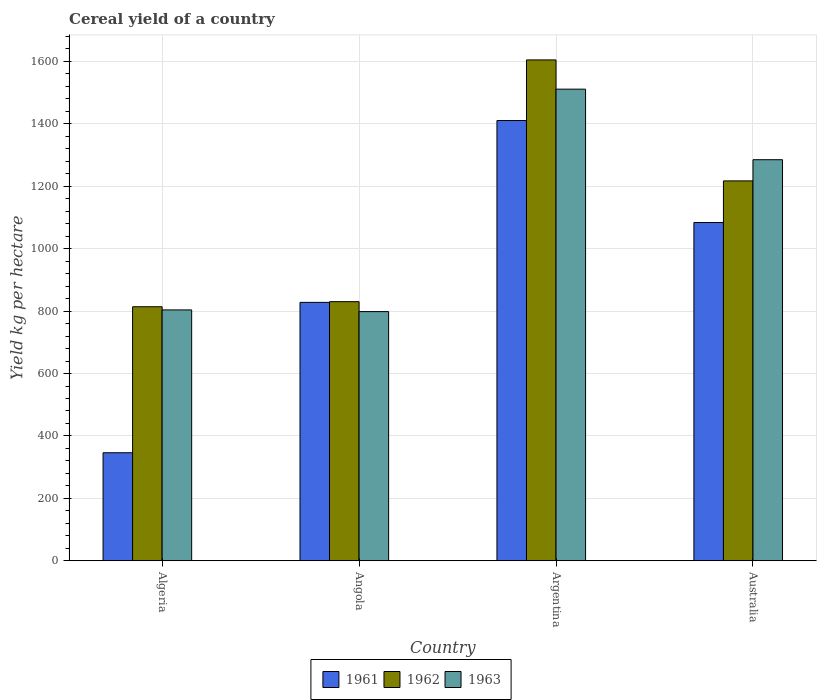Are the number of bars per tick equal to the number of legend labels?
Keep it short and to the point. Yes. Are the number of bars on each tick of the X-axis equal?
Keep it short and to the point. Yes. What is the label of the 1st group of bars from the left?
Ensure brevity in your answer.  Algeria. In how many cases, is the number of bars for a given country not equal to the number of legend labels?
Provide a succinct answer. 0. What is the total cereal yield in 1963 in Argentina?
Give a very brief answer. 1511.24. Across all countries, what is the maximum total cereal yield in 1962?
Your response must be concise. 1604.92. Across all countries, what is the minimum total cereal yield in 1963?
Your answer should be very brief. 798.45. In which country was the total cereal yield in 1961 maximum?
Offer a very short reply. Argentina. In which country was the total cereal yield in 1962 minimum?
Provide a succinct answer. Algeria. What is the total total cereal yield in 1962 in the graph?
Ensure brevity in your answer.  4466.47. What is the difference between the total cereal yield in 1961 in Algeria and that in Angola?
Keep it short and to the point. -481.85. What is the difference between the total cereal yield in 1961 in Angola and the total cereal yield in 1962 in Australia?
Keep it short and to the point. -389.26. What is the average total cereal yield in 1961 per country?
Your answer should be compact. 917.18. What is the difference between the total cereal yield of/in 1963 and total cereal yield of/in 1962 in Algeria?
Give a very brief answer. -10.17. What is the ratio of the total cereal yield in 1962 in Argentina to that in Australia?
Offer a very short reply. 1.32. Is the total cereal yield in 1962 in Angola less than that in Argentina?
Offer a very short reply. Yes. Is the difference between the total cereal yield in 1963 in Angola and Australia greater than the difference between the total cereal yield in 1962 in Angola and Australia?
Provide a short and direct response. No. What is the difference between the highest and the second highest total cereal yield in 1963?
Provide a short and direct response. -481.34. What is the difference between the highest and the lowest total cereal yield in 1961?
Your answer should be very brief. 1064.5. Is the sum of the total cereal yield in 1961 in Angola and Argentina greater than the maximum total cereal yield in 1962 across all countries?
Your answer should be compact. Yes. What does the 2nd bar from the right in Angola represents?
Give a very brief answer. 1962. Is it the case that in every country, the sum of the total cereal yield in 1962 and total cereal yield in 1963 is greater than the total cereal yield in 1961?
Offer a very short reply. Yes. How many bars are there?
Your answer should be compact. 12. How many countries are there in the graph?
Provide a short and direct response. 4. Are the values on the major ticks of Y-axis written in scientific E-notation?
Keep it short and to the point. No. Does the graph contain any zero values?
Ensure brevity in your answer.  No. How are the legend labels stacked?
Your answer should be very brief. Horizontal. What is the title of the graph?
Give a very brief answer. Cereal yield of a country. Does "1985" appear as one of the legend labels in the graph?
Offer a very short reply. No. What is the label or title of the Y-axis?
Your answer should be compact. Yield kg per hectare. What is the Yield kg per hectare of 1961 in Algeria?
Your response must be concise. 346.15. What is the Yield kg per hectare in 1962 in Algeria?
Offer a very short reply. 814. What is the Yield kg per hectare of 1963 in Algeria?
Provide a short and direct response. 803.83. What is the Yield kg per hectare of 1961 in Angola?
Offer a terse response. 828.01. What is the Yield kg per hectare in 1962 in Angola?
Your answer should be compact. 830.27. What is the Yield kg per hectare of 1963 in Angola?
Keep it short and to the point. 798.45. What is the Yield kg per hectare in 1961 in Argentina?
Your answer should be very brief. 1410.65. What is the Yield kg per hectare in 1962 in Argentina?
Give a very brief answer. 1604.92. What is the Yield kg per hectare of 1963 in Argentina?
Your response must be concise. 1511.24. What is the Yield kg per hectare in 1961 in Australia?
Provide a succinct answer. 1083.9. What is the Yield kg per hectare in 1962 in Australia?
Keep it short and to the point. 1217.27. What is the Yield kg per hectare in 1963 in Australia?
Ensure brevity in your answer.  1285.17. Across all countries, what is the maximum Yield kg per hectare in 1961?
Ensure brevity in your answer.  1410.65. Across all countries, what is the maximum Yield kg per hectare of 1962?
Offer a terse response. 1604.92. Across all countries, what is the maximum Yield kg per hectare of 1963?
Give a very brief answer. 1511.24. Across all countries, what is the minimum Yield kg per hectare of 1961?
Keep it short and to the point. 346.15. Across all countries, what is the minimum Yield kg per hectare in 1962?
Offer a terse response. 814. Across all countries, what is the minimum Yield kg per hectare in 1963?
Offer a terse response. 798.45. What is the total Yield kg per hectare of 1961 in the graph?
Offer a terse response. 3668.71. What is the total Yield kg per hectare of 1962 in the graph?
Make the answer very short. 4466.47. What is the total Yield kg per hectare in 1963 in the graph?
Your answer should be compact. 4398.7. What is the difference between the Yield kg per hectare of 1961 in Algeria and that in Angola?
Your answer should be very brief. -481.85. What is the difference between the Yield kg per hectare in 1962 in Algeria and that in Angola?
Your answer should be very brief. -16.27. What is the difference between the Yield kg per hectare in 1963 in Algeria and that in Angola?
Make the answer very short. 5.38. What is the difference between the Yield kg per hectare in 1961 in Algeria and that in Argentina?
Your answer should be compact. -1064.5. What is the difference between the Yield kg per hectare in 1962 in Algeria and that in Argentina?
Provide a succinct answer. -790.92. What is the difference between the Yield kg per hectare in 1963 in Algeria and that in Argentina?
Offer a terse response. -707.41. What is the difference between the Yield kg per hectare of 1961 in Algeria and that in Australia?
Your answer should be very brief. -737.75. What is the difference between the Yield kg per hectare in 1962 in Algeria and that in Australia?
Your answer should be very brief. -403.27. What is the difference between the Yield kg per hectare in 1963 in Algeria and that in Australia?
Your answer should be very brief. -481.34. What is the difference between the Yield kg per hectare in 1961 in Angola and that in Argentina?
Offer a terse response. -582.65. What is the difference between the Yield kg per hectare of 1962 in Angola and that in Argentina?
Your answer should be compact. -774.65. What is the difference between the Yield kg per hectare in 1963 in Angola and that in Argentina?
Provide a succinct answer. -712.79. What is the difference between the Yield kg per hectare of 1961 in Angola and that in Australia?
Give a very brief answer. -255.9. What is the difference between the Yield kg per hectare of 1962 in Angola and that in Australia?
Keep it short and to the point. -387. What is the difference between the Yield kg per hectare of 1963 in Angola and that in Australia?
Make the answer very short. -486.72. What is the difference between the Yield kg per hectare of 1961 in Argentina and that in Australia?
Make the answer very short. 326.75. What is the difference between the Yield kg per hectare in 1962 in Argentina and that in Australia?
Ensure brevity in your answer.  387.65. What is the difference between the Yield kg per hectare in 1963 in Argentina and that in Australia?
Offer a very short reply. 226.07. What is the difference between the Yield kg per hectare in 1961 in Algeria and the Yield kg per hectare in 1962 in Angola?
Ensure brevity in your answer.  -484.12. What is the difference between the Yield kg per hectare in 1961 in Algeria and the Yield kg per hectare in 1963 in Angola?
Keep it short and to the point. -452.3. What is the difference between the Yield kg per hectare in 1962 in Algeria and the Yield kg per hectare in 1963 in Angola?
Your answer should be very brief. 15.55. What is the difference between the Yield kg per hectare in 1961 in Algeria and the Yield kg per hectare in 1962 in Argentina?
Your answer should be very brief. -1258.77. What is the difference between the Yield kg per hectare in 1961 in Algeria and the Yield kg per hectare in 1963 in Argentina?
Offer a terse response. -1165.09. What is the difference between the Yield kg per hectare of 1962 in Algeria and the Yield kg per hectare of 1963 in Argentina?
Your response must be concise. -697.24. What is the difference between the Yield kg per hectare in 1961 in Algeria and the Yield kg per hectare in 1962 in Australia?
Your response must be concise. -871.12. What is the difference between the Yield kg per hectare of 1961 in Algeria and the Yield kg per hectare of 1963 in Australia?
Your response must be concise. -939.02. What is the difference between the Yield kg per hectare in 1962 in Algeria and the Yield kg per hectare in 1963 in Australia?
Offer a terse response. -471.17. What is the difference between the Yield kg per hectare in 1961 in Angola and the Yield kg per hectare in 1962 in Argentina?
Keep it short and to the point. -776.92. What is the difference between the Yield kg per hectare of 1961 in Angola and the Yield kg per hectare of 1963 in Argentina?
Offer a very short reply. -683.24. What is the difference between the Yield kg per hectare of 1962 in Angola and the Yield kg per hectare of 1963 in Argentina?
Offer a terse response. -680.97. What is the difference between the Yield kg per hectare of 1961 in Angola and the Yield kg per hectare of 1962 in Australia?
Your response must be concise. -389.26. What is the difference between the Yield kg per hectare in 1961 in Angola and the Yield kg per hectare in 1963 in Australia?
Provide a short and direct response. -457.17. What is the difference between the Yield kg per hectare in 1962 in Angola and the Yield kg per hectare in 1963 in Australia?
Your response must be concise. -454.9. What is the difference between the Yield kg per hectare in 1961 in Argentina and the Yield kg per hectare in 1962 in Australia?
Provide a succinct answer. 193.38. What is the difference between the Yield kg per hectare of 1961 in Argentina and the Yield kg per hectare of 1963 in Australia?
Provide a short and direct response. 125.48. What is the difference between the Yield kg per hectare of 1962 in Argentina and the Yield kg per hectare of 1963 in Australia?
Keep it short and to the point. 319.75. What is the average Yield kg per hectare of 1961 per country?
Make the answer very short. 917.18. What is the average Yield kg per hectare of 1962 per country?
Your answer should be very brief. 1116.62. What is the average Yield kg per hectare in 1963 per country?
Keep it short and to the point. 1099.67. What is the difference between the Yield kg per hectare in 1961 and Yield kg per hectare in 1962 in Algeria?
Provide a short and direct response. -467.85. What is the difference between the Yield kg per hectare of 1961 and Yield kg per hectare of 1963 in Algeria?
Your answer should be compact. -457.68. What is the difference between the Yield kg per hectare in 1962 and Yield kg per hectare in 1963 in Algeria?
Your answer should be very brief. 10.17. What is the difference between the Yield kg per hectare of 1961 and Yield kg per hectare of 1962 in Angola?
Offer a very short reply. -2.27. What is the difference between the Yield kg per hectare of 1961 and Yield kg per hectare of 1963 in Angola?
Your answer should be compact. 29.56. What is the difference between the Yield kg per hectare of 1962 and Yield kg per hectare of 1963 in Angola?
Your answer should be compact. 31.82. What is the difference between the Yield kg per hectare of 1961 and Yield kg per hectare of 1962 in Argentina?
Your answer should be very brief. -194.27. What is the difference between the Yield kg per hectare of 1961 and Yield kg per hectare of 1963 in Argentina?
Provide a succinct answer. -100.59. What is the difference between the Yield kg per hectare in 1962 and Yield kg per hectare in 1963 in Argentina?
Provide a succinct answer. 93.68. What is the difference between the Yield kg per hectare of 1961 and Yield kg per hectare of 1962 in Australia?
Your answer should be compact. -133.37. What is the difference between the Yield kg per hectare in 1961 and Yield kg per hectare in 1963 in Australia?
Ensure brevity in your answer.  -201.27. What is the difference between the Yield kg per hectare of 1962 and Yield kg per hectare of 1963 in Australia?
Offer a very short reply. -67.9. What is the ratio of the Yield kg per hectare of 1961 in Algeria to that in Angola?
Your response must be concise. 0.42. What is the ratio of the Yield kg per hectare of 1962 in Algeria to that in Angola?
Make the answer very short. 0.98. What is the ratio of the Yield kg per hectare in 1963 in Algeria to that in Angola?
Your answer should be very brief. 1.01. What is the ratio of the Yield kg per hectare in 1961 in Algeria to that in Argentina?
Provide a short and direct response. 0.25. What is the ratio of the Yield kg per hectare of 1962 in Algeria to that in Argentina?
Provide a short and direct response. 0.51. What is the ratio of the Yield kg per hectare in 1963 in Algeria to that in Argentina?
Provide a short and direct response. 0.53. What is the ratio of the Yield kg per hectare in 1961 in Algeria to that in Australia?
Provide a succinct answer. 0.32. What is the ratio of the Yield kg per hectare in 1962 in Algeria to that in Australia?
Offer a terse response. 0.67. What is the ratio of the Yield kg per hectare in 1963 in Algeria to that in Australia?
Provide a short and direct response. 0.63. What is the ratio of the Yield kg per hectare in 1961 in Angola to that in Argentina?
Keep it short and to the point. 0.59. What is the ratio of the Yield kg per hectare of 1962 in Angola to that in Argentina?
Provide a short and direct response. 0.52. What is the ratio of the Yield kg per hectare in 1963 in Angola to that in Argentina?
Your answer should be very brief. 0.53. What is the ratio of the Yield kg per hectare of 1961 in Angola to that in Australia?
Give a very brief answer. 0.76. What is the ratio of the Yield kg per hectare in 1962 in Angola to that in Australia?
Keep it short and to the point. 0.68. What is the ratio of the Yield kg per hectare of 1963 in Angola to that in Australia?
Your answer should be very brief. 0.62. What is the ratio of the Yield kg per hectare in 1961 in Argentina to that in Australia?
Offer a terse response. 1.3. What is the ratio of the Yield kg per hectare in 1962 in Argentina to that in Australia?
Offer a terse response. 1.32. What is the ratio of the Yield kg per hectare of 1963 in Argentina to that in Australia?
Offer a terse response. 1.18. What is the difference between the highest and the second highest Yield kg per hectare of 1961?
Provide a succinct answer. 326.75. What is the difference between the highest and the second highest Yield kg per hectare in 1962?
Provide a succinct answer. 387.65. What is the difference between the highest and the second highest Yield kg per hectare of 1963?
Provide a succinct answer. 226.07. What is the difference between the highest and the lowest Yield kg per hectare in 1961?
Your answer should be very brief. 1064.5. What is the difference between the highest and the lowest Yield kg per hectare of 1962?
Give a very brief answer. 790.92. What is the difference between the highest and the lowest Yield kg per hectare in 1963?
Your answer should be compact. 712.79. 